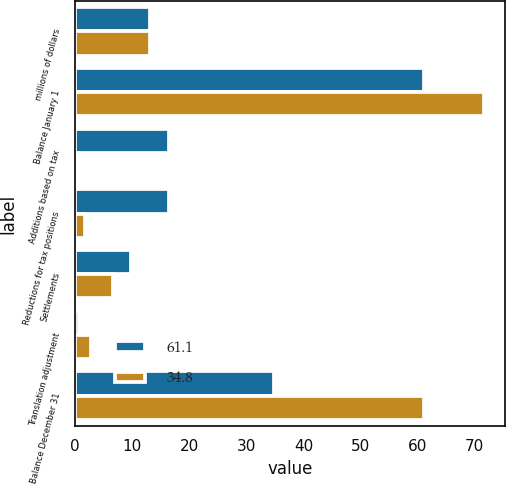Convert chart to OTSL. <chart><loc_0><loc_0><loc_500><loc_500><stacked_bar_chart><ecel><fcel>millions of dollars<fcel>Balance January 1<fcel>Additions based on tax<fcel>Reductions for tax positions<fcel>Settlements<fcel>Translation adjustment<fcel>Balance December 31<nl><fcel>61.1<fcel>13.15<fcel>61.1<fcel>16.4<fcel>16.5<fcel>9.9<fcel>0.7<fcel>34.8<nl><fcel>34.8<fcel>13.15<fcel>71.7<fcel>0.5<fcel>1.7<fcel>6.7<fcel>2.9<fcel>61.1<nl></chart> 